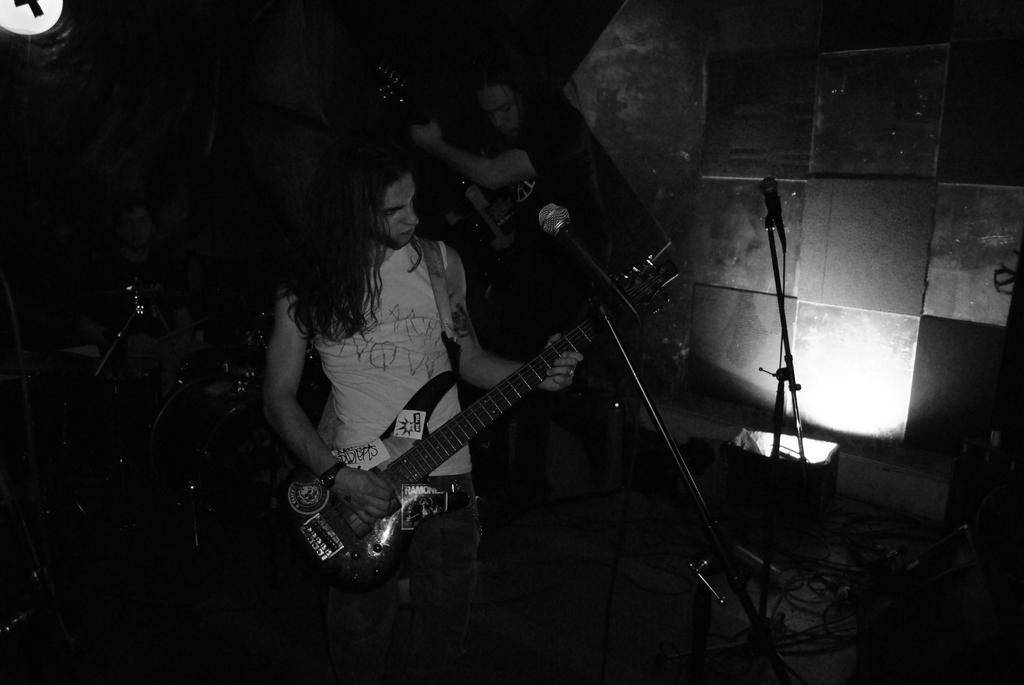What is the man in the image holding? The man is holding a guitar in the image. What is the purpose of the microphone in the image? The microphone is held on a mic stand, suggesting it is being used for amplifying sound. Can you describe the lighting in the image? There is a light on the wall in the image. How would you describe the overall setting of the image? The background of the image is dark, and there are other musicians playing instruments in the background. What type of calculator is the man using to play the guitar in the image? There is no calculator present in the image, and the man is not using any device to play the guitar. What kind of patch is sewn onto the guitar in the image? There is no patch visible on the guitar in the image. 